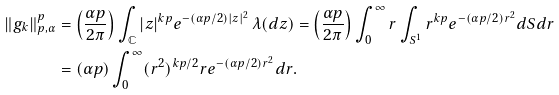<formula> <loc_0><loc_0><loc_500><loc_500>\| g _ { k } \| _ { p , \alpha } ^ { p } & = \left ( \frac { \alpha p } { 2 \pi } \right ) \int _ { \mathbb { C } } | z | ^ { k p } e ^ { - ( \alpha p / 2 ) | z | ^ { 2 } } \, \lambda ( d z ) = \left ( \frac { \alpha p } { 2 \pi } \right ) \int _ { 0 } ^ { \infty } r \int _ { S ^ { 1 } } r ^ { k p } e ^ { - ( \alpha p / 2 ) r ^ { 2 } } d S d r \\ & = ( \alpha p ) \int _ { 0 } ^ { \infty } ( r ^ { 2 } ) ^ { k p / 2 } r e ^ { - ( \alpha p / 2 ) r ^ { 2 } } d r .</formula> 